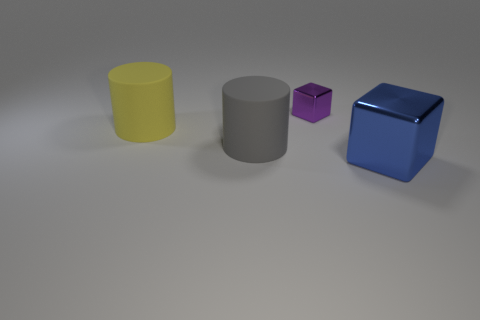Are there any other things that are the same size as the purple cube?
Offer a very short reply. No. Are the cube right of the small purple shiny cube and the small object made of the same material?
Keep it short and to the point. Yes. What number of objects are metal cubes on the left side of the big blue shiny thing or tiny green metallic things?
Provide a short and direct response. 1. There is a big block that is the same material as the small purple block; what color is it?
Your response must be concise. Blue. Is there another blue cube of the same size as the blue shiny block?
Give a very brief answer. No. There is a object that is to the right of the big gray matte cylinder and left of the big blue object; what is its color?
Offer a very short reply. Purple. There is a blue metallic object that is the same size as the gray rubber cylinder; what is its shape?
Provide a short and direct response. Cube. Are there any blue things of the same shape as the small purple object?
Provide a short and direct response. Yes. Do the matte cylinder that is in front of the yellow cylinder and the large shiny object have the same size?
Provide a succinct answer. Yes. There is a thing that is both in front of the yellow matte cylinder and behind the large blue metal cube; what is its size?
Your response must be concise. Large. 